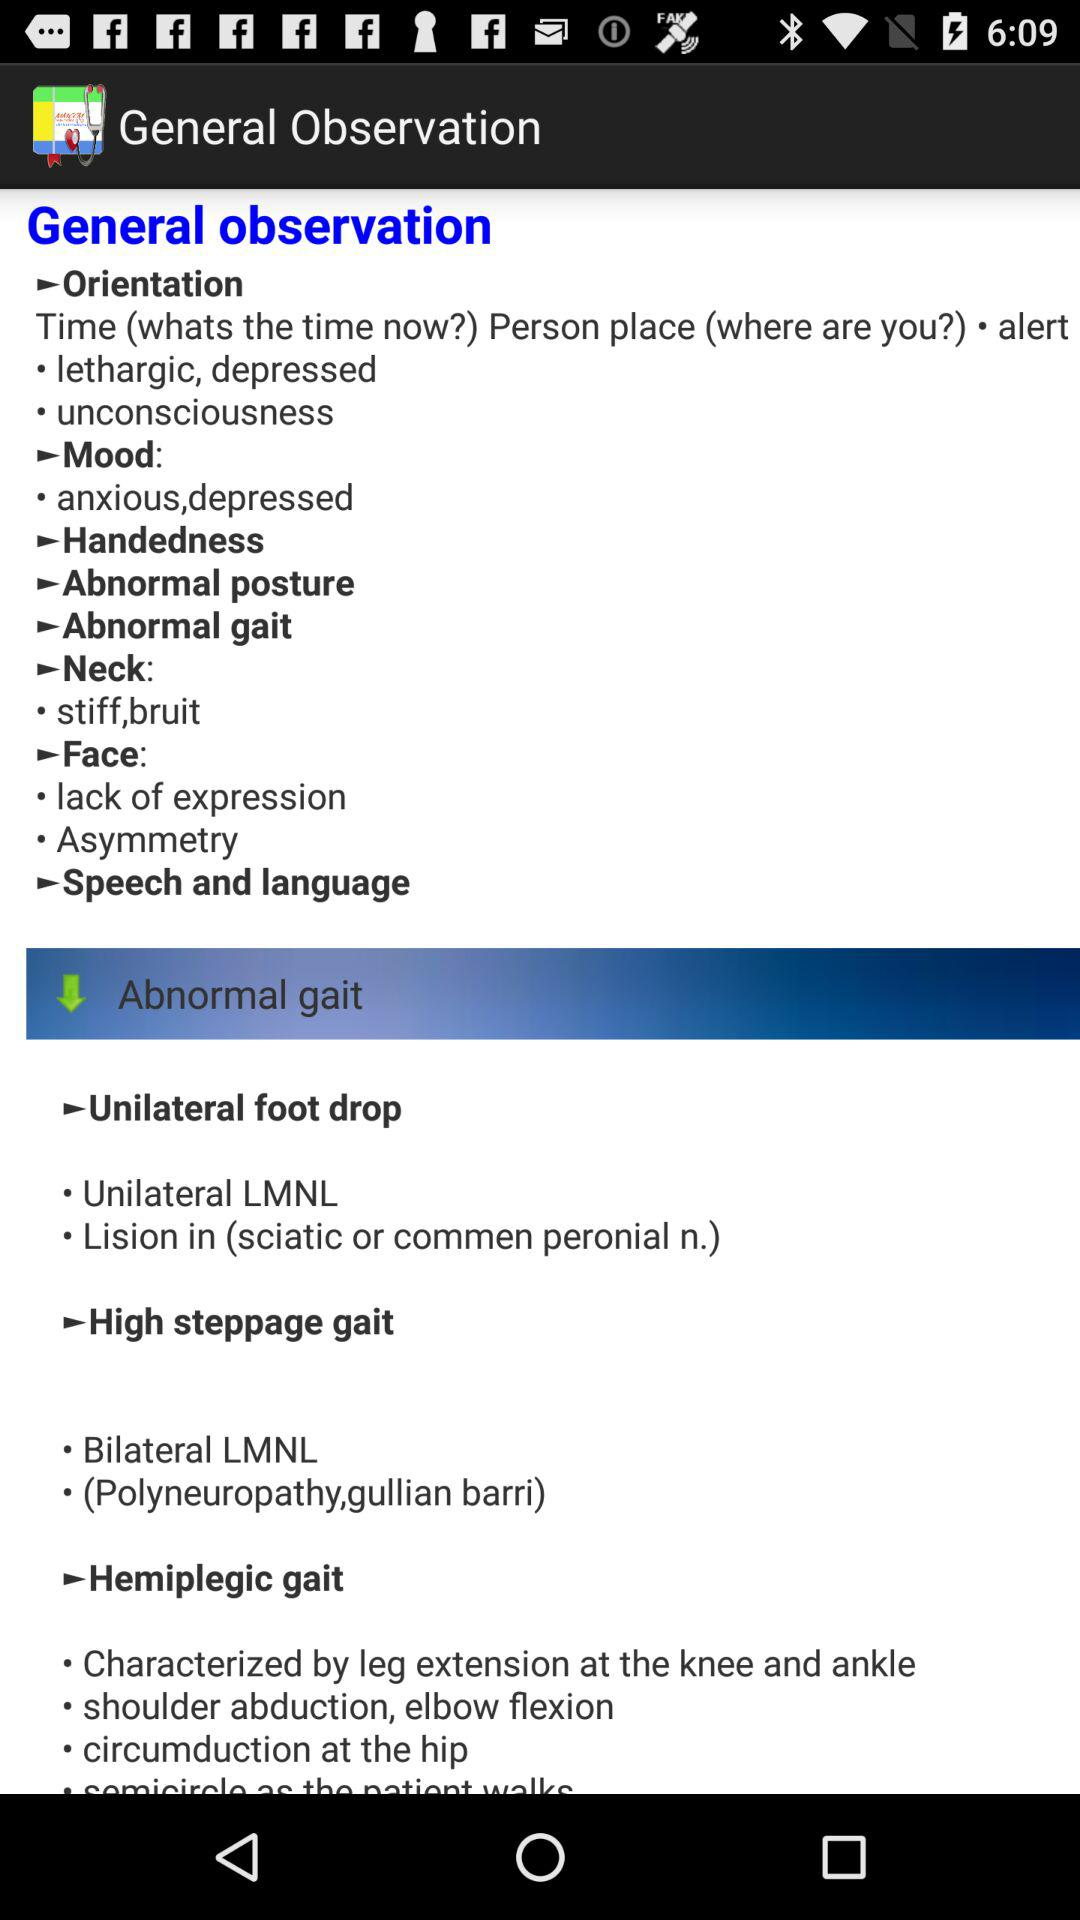What is the general observation under "High steppage gait"? The general observations are "Bilateral LMNL" and "(Polyneuropathy,gullian barri)". 